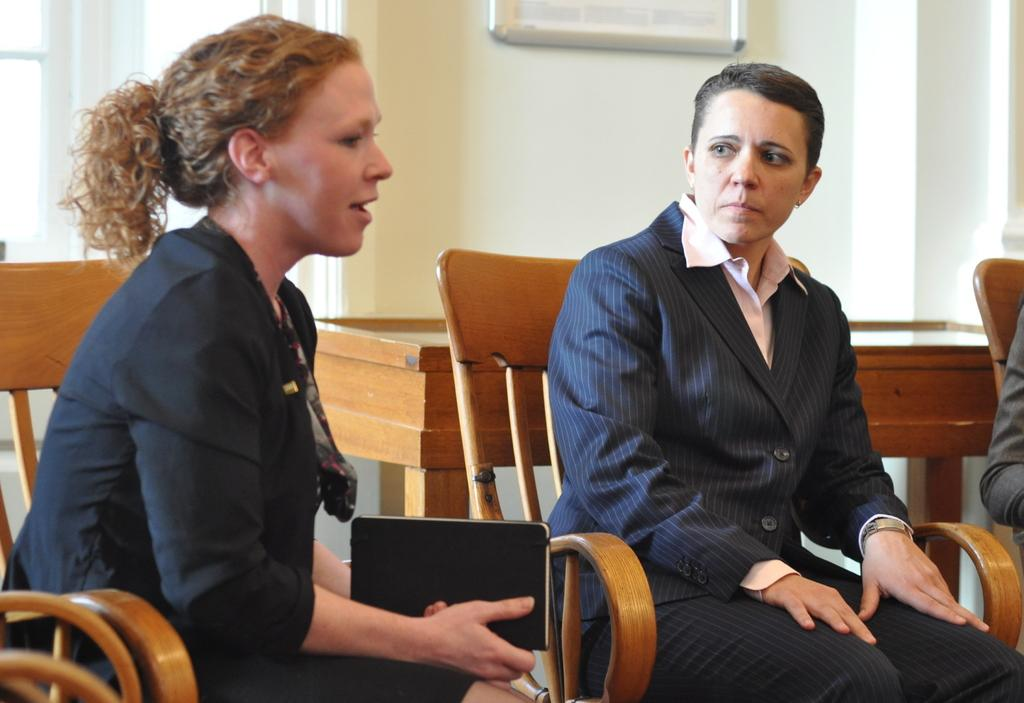How many people are in the image? There are two women in the image. What are the women doing in the image? The women are sitting on a chair. What is present in the image besides the women? There is a table and a wall in the image. What type of stamp can be seen on the wall in the image? There is no stamp present on the wall in the image. What flavor of juice is being served on the table in the image? There is no juice present on the table in the image. 